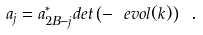<formula> <loc_0><loc_0><loc_500><loc_500>a _ { j } = a _ { 2 B - j } ^ { * } d e t \left ( - \ e v o l ( k ) \right ) \ .</formula> 